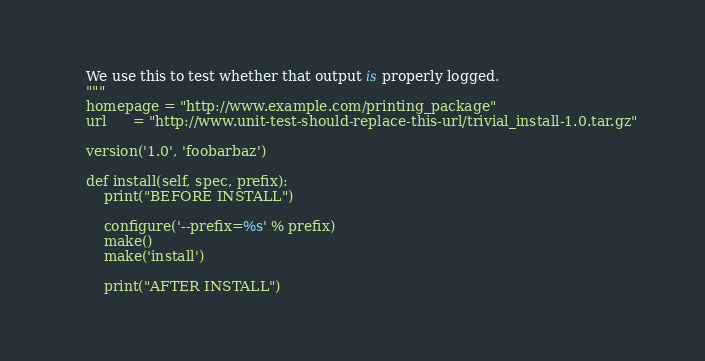Convert code to text. <code><loc_0><loc_0><loc_500><loc_500><_Python_>
    We use this to test whether that output is properly logged.
    """
    homepage = "http://www.example.com/printing_package"
    url      = "http://www.unit-test-should-replace-this-url/trivial_install-1.0.tar.gz"

    version('1.0', 'foobarbaz')

    def install(self, spec, prefix):
        print("BEFORE INSTALL")

        configure('--prefix=%s' % prefix)
        make()
        make('install')

        print("AFTER INSTALL")
</code> 